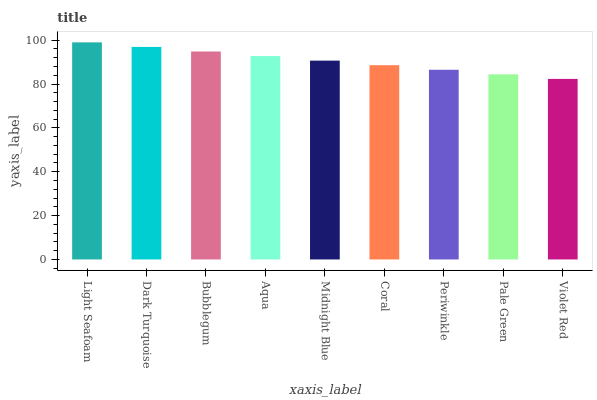Is Violet Red the minimum?
Answer yes or no. Yes. Is Light Seafoam the maximum?
Answer yes or no. Yes. Is Dark Turquoise the minimum?
Answer yes or no. No. Is Dark Turquoise the maximum?
Answer yes or no. No. Is Light Seafoam greater than Dark Turquoise?
Answer yes or no. Yes. Is Dark Turquoise less than Light Seafoam?
Answer yes or no. Yes. Is Dark Turquoise greater than Light Seafoam?
Answer yes or no. No. Is Light Seafoam less than Dark Turquoise?
Answer yes or no. No. Is Midnight Blue the high median?
Answer yes or no. Yes. Is Midnight Blue the low median?
Answer yes or no. Yes. Is Bubblegum the high median?
Answer yes or no. No. Is Periwinkle the low median?
Answer yes or no. No. 